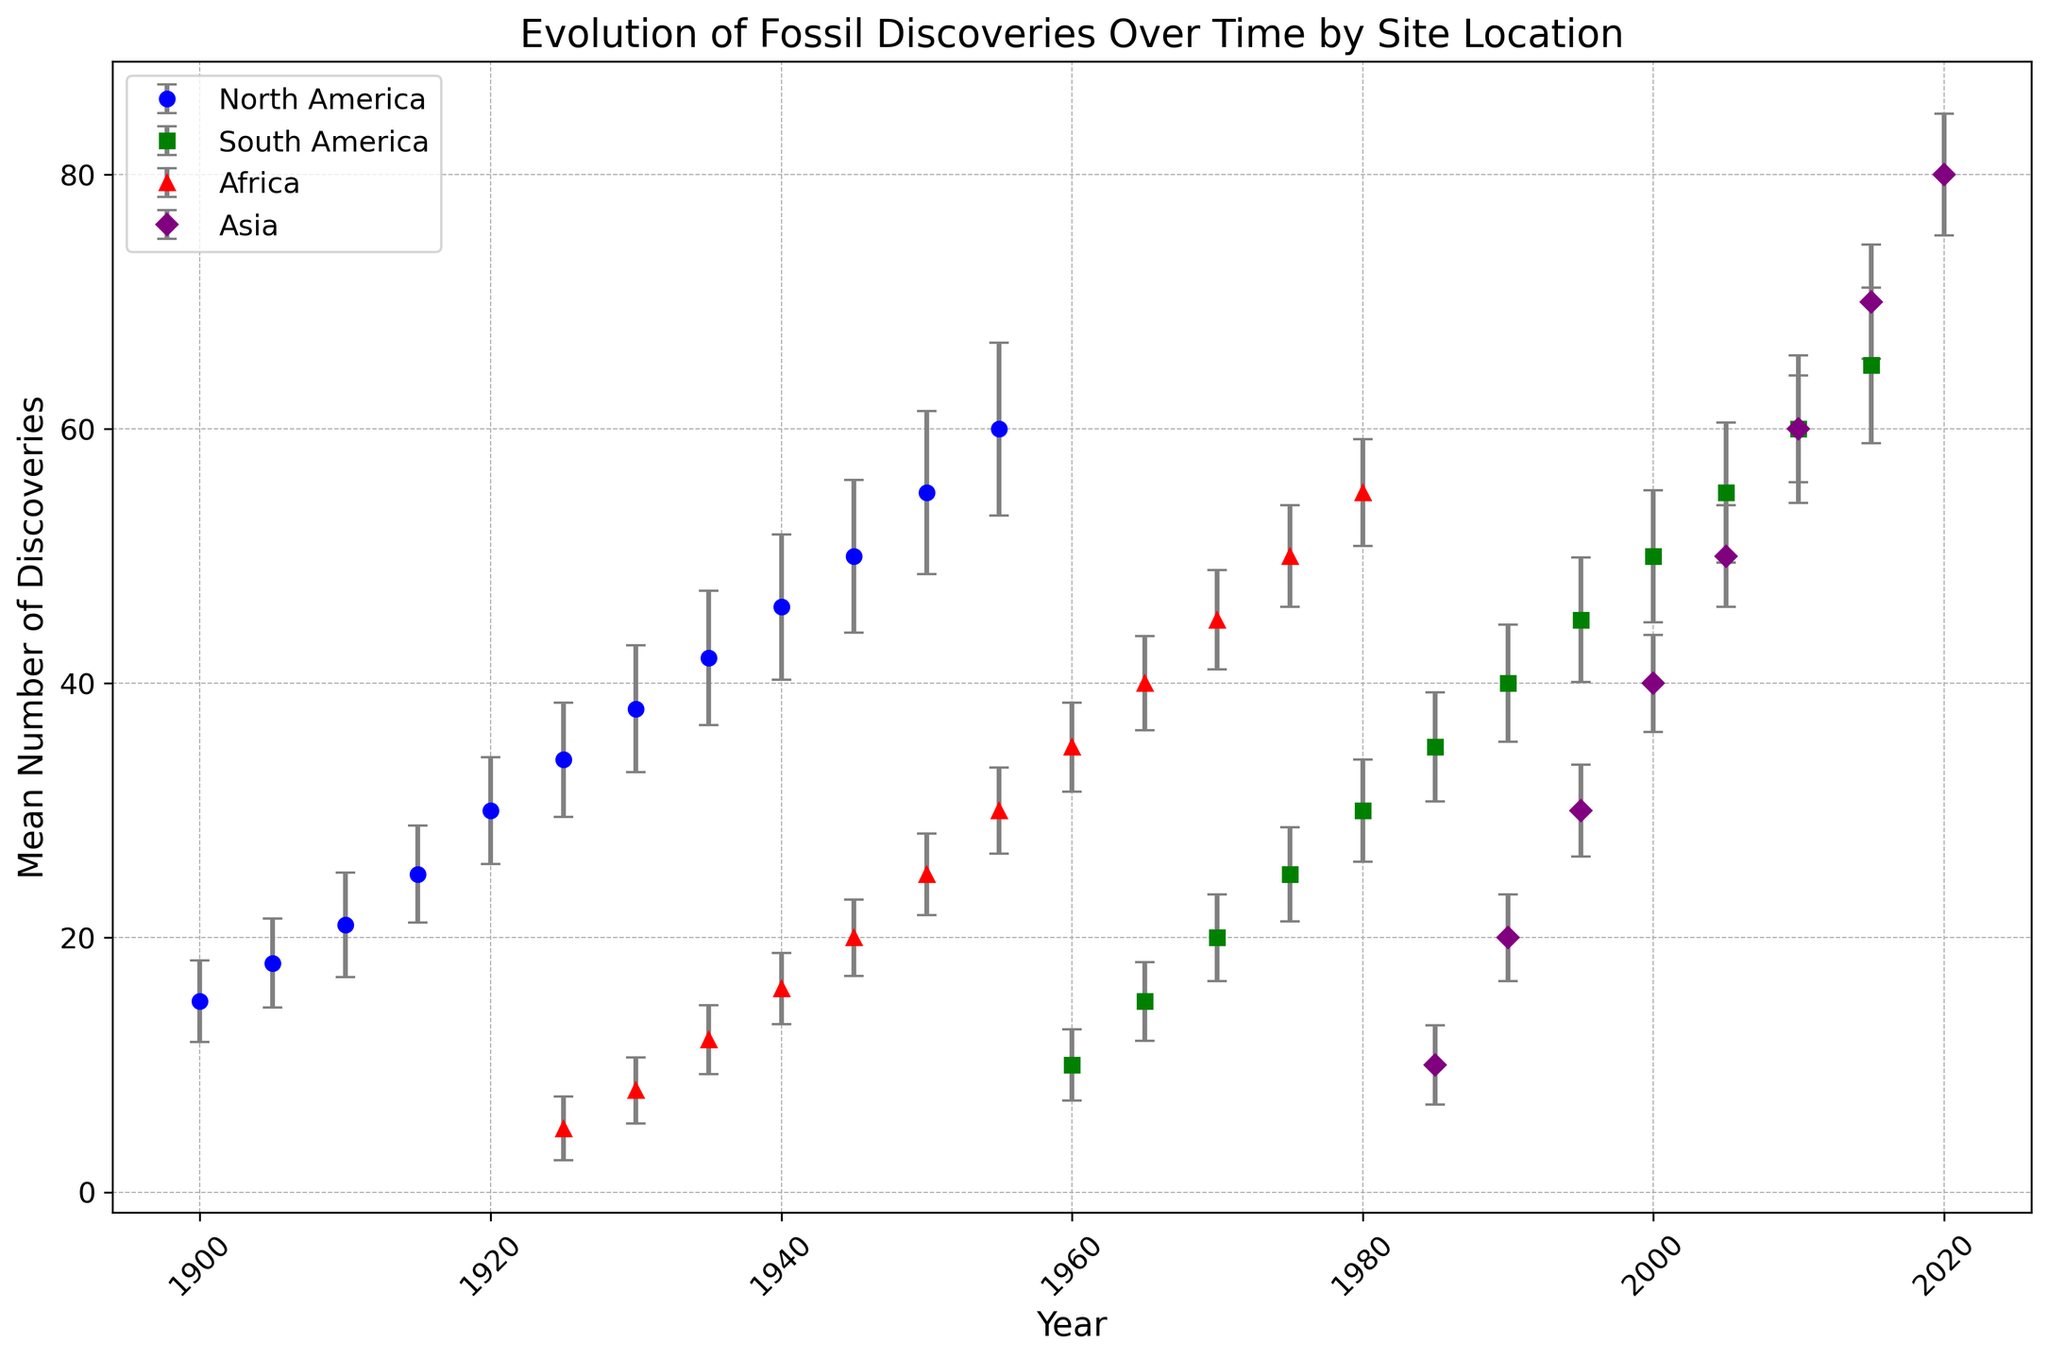What's the general trend of fossil discoveries in North America over time? The mean number of discoveries in North America increases steadily from 15 in 1900 to 60 in 1955.
Answer: Increasing Between 1960 and 2000, which location had a higher number of discoveries on average: South America or Africa? Calculate the average of the mean discoveries for each location within that period. South America: (10+15+20+25+30+35+40+45+50) / 9 = 30; Africa: (35+40+45+50) / 4 = 42.5. Hence, Africa had a higher average.
Answer: Africa How do the standard deviations of discoveries in Asia in 2010 and South America in 2010 compare? The standard deviation of discoveries in Asia in 2010 is 4.2, while in South America, it is 5.8. Therefore, South America has a higher standard deviation.
Answer: South America has a higher standard deviation What is the mean number of discoveries in Asia in 2015? Locate the data point for Asia in 2015, which records a mean discovery of 70.
Answer: 70 In which year did Africa first surpass a mean of 30 discoveries? Check the mean discoveries for Africa year-by-year until it first exceeds 30. This happens in 1955.
Answer: 1955 Which region showed the most accelerated increase in fossil discoveries over the recorded years? Compare the slope of the increase in discoveries for each region. Asia shows the most accelerated increase, starting from 10 in 1985 to 80 in 2020.
Answer: Asia Between 1935 and 1940, how did the mean number of discoveries in Africa change? Subtract the 1935 value (12) from the 1940 value (16), yielding an increase of 4.
Answer: Increased by 4 What pattern is observed about the discoveries in North America from 1900 to 1955, when compared to those in South America from 1960 to 2015? Both regions show a steady linear increase in the mean number of discoveries over their respective periods.
Answer: Steady linear increase Which location had the lowest mean number of discoveries at the start of the records? The earliest recorded mean for Africa in 1925 is 5, which is the lowest when compared to other initial records in 1900 for North America and 1960 for South America and Asia.
Answer: Africa 